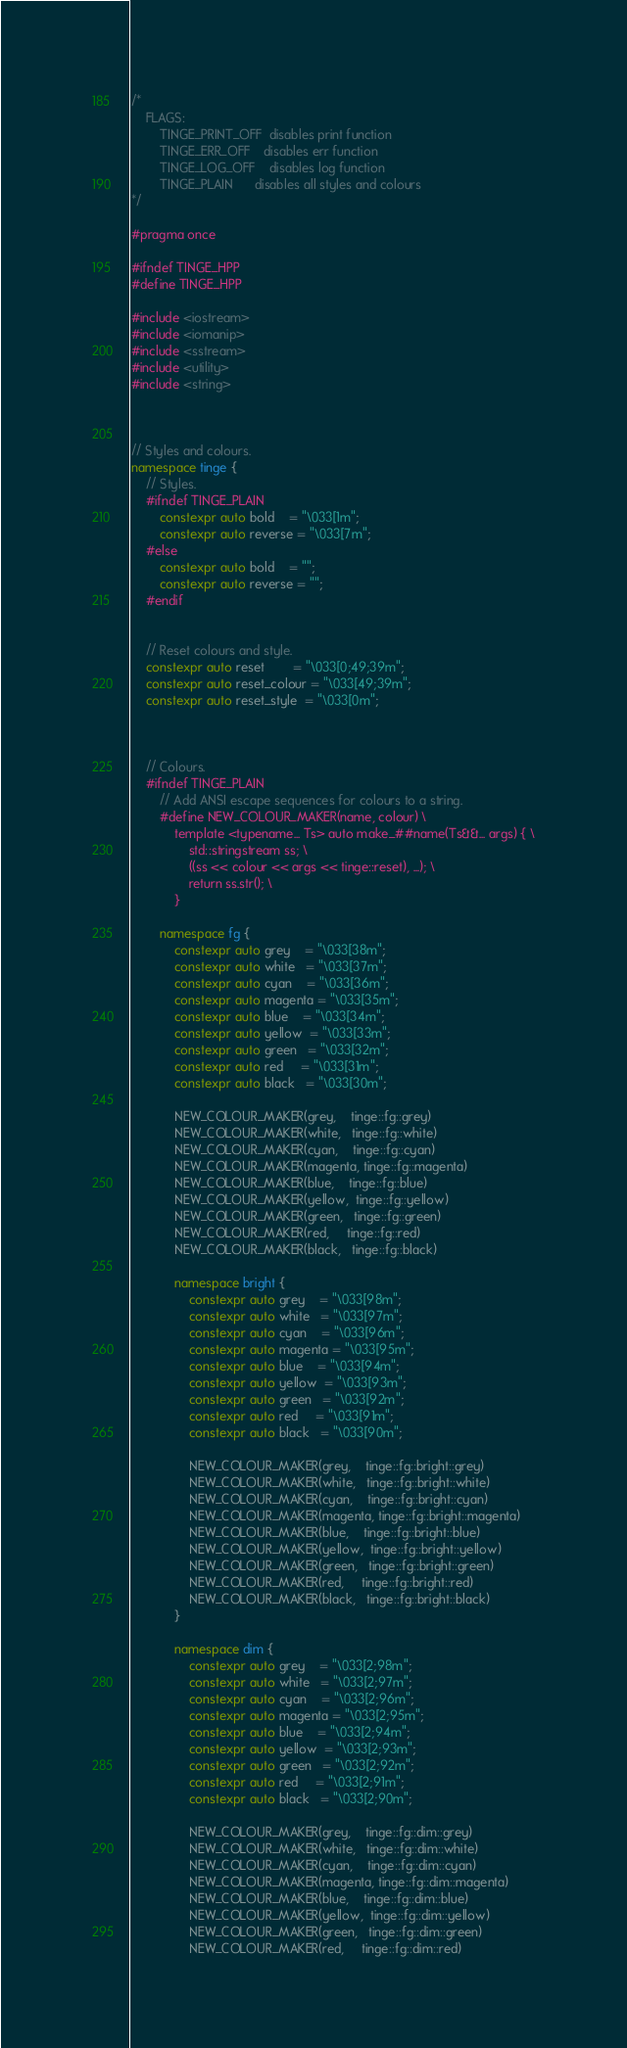<code> <loc_0><loc_0><loc_500><loc_500><_C++_>/*
	FLAGS:
		TINGE_PRINT_OFF  disables print function
		TINGE_ERR_OFF    disables err function
		TINGE_LOG_OFF    disables log function
		TINGE_PLAIN      disables all styles and colours
*/

#pragma once

#ifndef TINGE_HPP
#define TINGE_HPP

#include <iostream>
#include <iomanip>
#include <sstream>
#include <utility>
#include <string>



// Styles and colours.
namespace tinge {
	// Styles.
	#ifndef TINGE_PLAIN
		constexpr auto bold    = "\033[1m";
		constexpr auto reverse = "\033[7m";
	#else
		constexpr auto bold    = "";
		constexpr auto reverse = "";
	#endif


	// Reset colours and style.
	constexpr auto reset        = "\033[0;49;39m";
	constexpr auto reset_colour = "\033[49;39m";
	constexpr auto reset_style  = "\033[0m";



	// Colours.
	#ifndef TINGE_PLAIN
		// Add ANSI escape sequences for colours to a string.
		#define NEW_COLOUR_MAKER(name, colour) \
			template <typename... Ts> auto make_##name(Ts&&... args) { \
				std::stringstream ss; \
				((ss << colour << args << tinge::reset), ...); \
				return ss.str(); \
			}

		namespace fg {
			constexpr auto grey    = "\033[38m";
			constexpr auto white   = "\033[37m";
			constexpr auto cyan    = "\033[36m";
			constexpr auto magenta = "\033[35m";
			constexpr auto blue    = "\033[34m";
			constexpr auto yellow  = "\033[33m";
			constexpr auto green   = "\033[32m";
			constexpr auto red     = "\033[31m";
			constexpr auto black   = "\033[30m";

			NEW_COLOUR_MAKER(grey,    tinge::fg::grey)
			NEW_COLOUR_MAKER(white,   tinge::fg::white)
			NEW_COLOUR_MAKER(cyan,    tinge::fg::cyan)
			NEW_COLOUR_MAKER(magenta, tinge::fg::magenta)
			NEW_COLOUR_MAKER(blue,    tinge::fg::blue)
			NEW_COLOUR_MAKER(yellow,  tinge::fg::yellow)
			NEW_COLOUR_MAKER(green,   tinge::fg::green)
			NEW_COLOUR_MAKER(red,     tinge::fg::red)
			NEW_COLOUR_MAKER(black,   tinge::fg::black)

			namespace bright {
				constexpr auto grey    = "\033[98m";
				constexpr auto white   = "\033[97m";
				constexpr auto cyan    = "\033[96m";
				constexpr auto magenta = "\033[95m";
				constexpr auto blue    = "\033[94m";
				constexpr auto yellow  = "\033[93m";
				constexpr auto green   = "\033[92m";
				constexpr auto red     = "\033[91m";
				constexpr auto black   = "\033[90m";

				NEW_COLOUR_MAKER(grey,    tinge::fg::bright::grey)
				NEW_COLOUR_MAKER(white,   tinge::fg::bright::white)
				NEW_COLOUR_MAKER(cyan,    tinge::fg::bright::cyan)
				NEW_COLOUR_MAKER(magenta, tinge::fg::bright::magenta)
				NEW_COLOUR_MAKER(blue,    tinge::fg::bright::blue)
				NEW_COLOUR_MAKER(yellow,  tinge::fg::bright::yellow)
				NEW_COLOUR_MAKER(green,   tinge::fg::bright::green)
				NEW_COLOUR_MAKER(red,     tinge::fg::bright::red)
				NEW_COLOUR_MAKER(black,   tinge::fg::bright::black)
			}

			namespace dim {
				constexpr auto grey    = "\033[2;98m";
				constexpr auto white   = "\033[2;97m";
				constexpr auto cyan    = "\033[2;96m";
				constexpr auto magenta = "\033[2;95m";
				constexpr auto blue    = "\033[2;94m";
				constexpr auto yellow  = "\033[2;93m";
				constexpr auto green   = "\033[2;92m";
				constexpr auto red     = "\033[2;91m";
				constexpr auto black   = "\033[2;90m";

				NEW_COLOUR_MAKER(grey,    tinge::fg::dim::grey)
				NEW_COLOUR_MAKER(white,   tinge::fg::dim::white)
				NEW_COLOUR_MAKER(cyan,    tinge::fg::dim::cyan)
				NEW_COLOUR_MAKER(magenta, tinge::fg::dim::magenta)
				NEW_COLOUR_MAKER(blue,    tinge::fg::dim::blue)
				NEW_COLOUR_MAKER(yellow,  tinge::fg::dim::yellow)
				NEW_COLOUR_MAKER(green,   tinge::fg::dim::green)
				NEW_COLOUR_MAKER(red,     tinge::fg::dim::red)</code> 